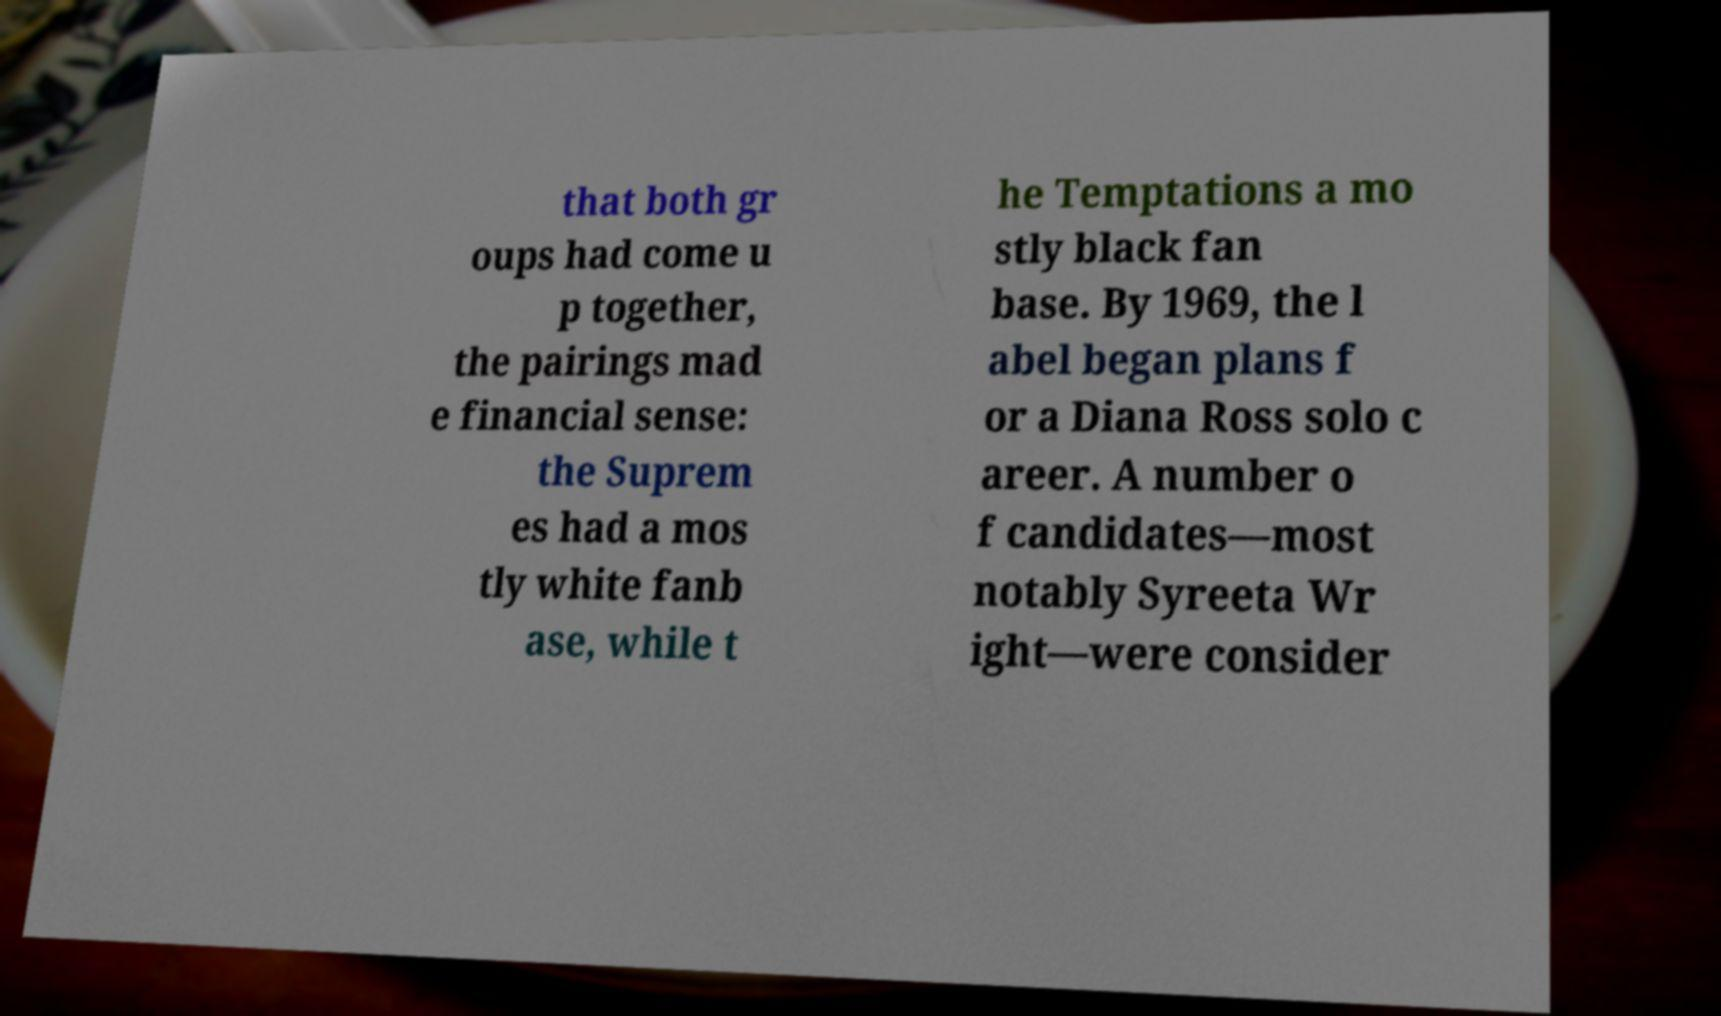I need the written content from this picture converted into text. Can you do that? that both gr oups had come u p together, the pairings mad e financial sense: the Suprem es had a mos tly white fanb ase, while t he Temptations a mo stly black fan base. By 1969, the l abel began plans f or a Diana Ross solo c areer. A number o f candidates—most notably Syreeta Wr ight—were consider 